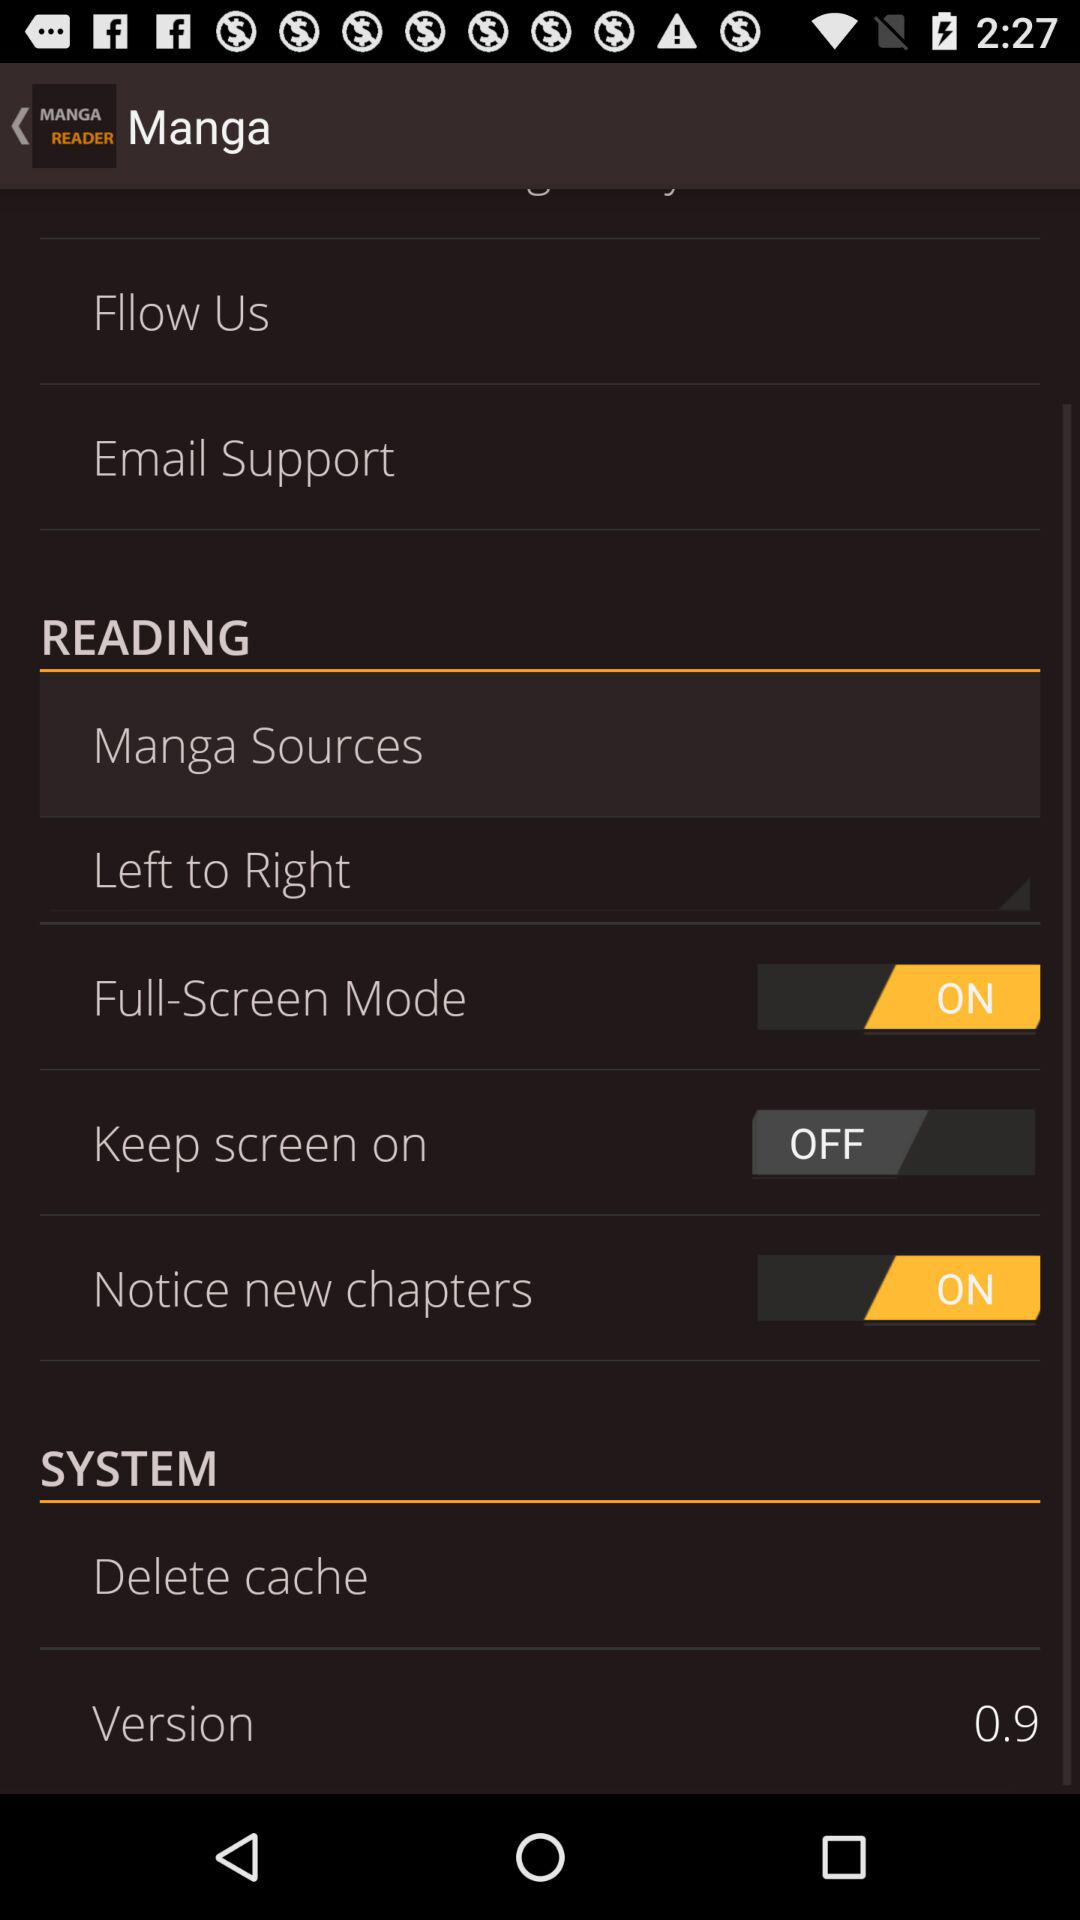What is the version? The version is 0.9. 